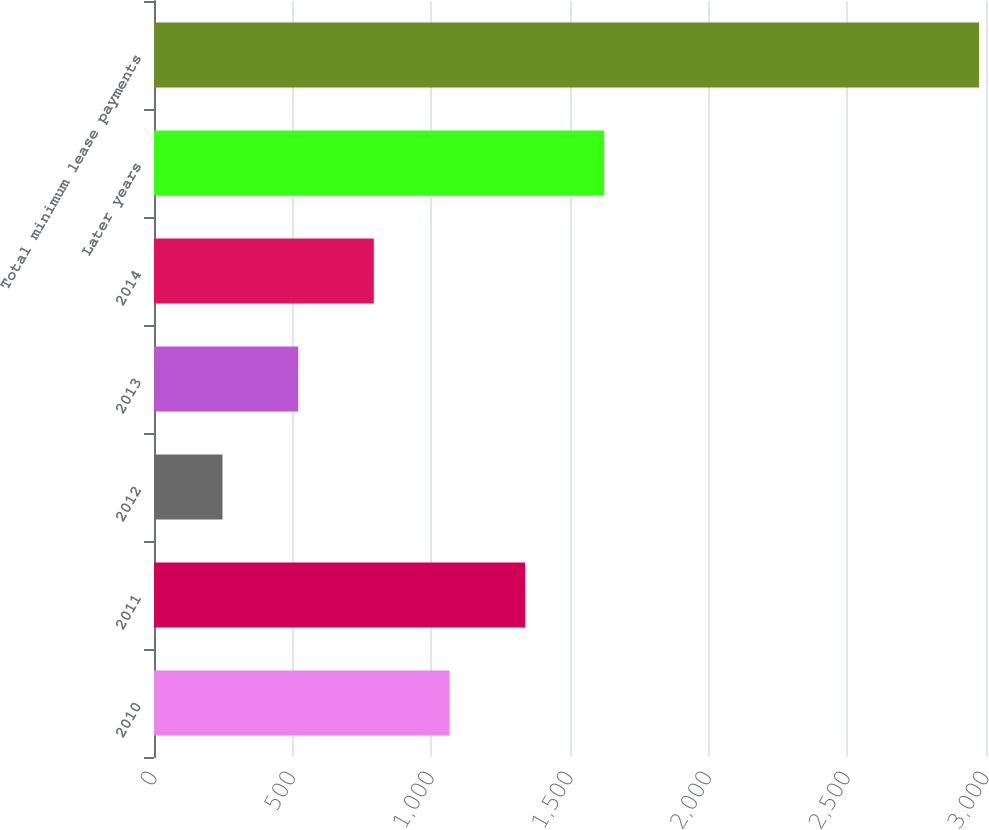<chart> <loc_0><loc_0><loc_500><loc_500><bar_chart><fcel>2010<fcel>2011<fcel>2012<fcel>2013<fcel>2014<fcel>Later years<fcel>Total minimum lease payments<nl><fcel>1065.4<fcel>1338.2<fcel>247<fcel>519.8<fcel>792.6<fcel>1623<fcel>2975<nl></chart> 